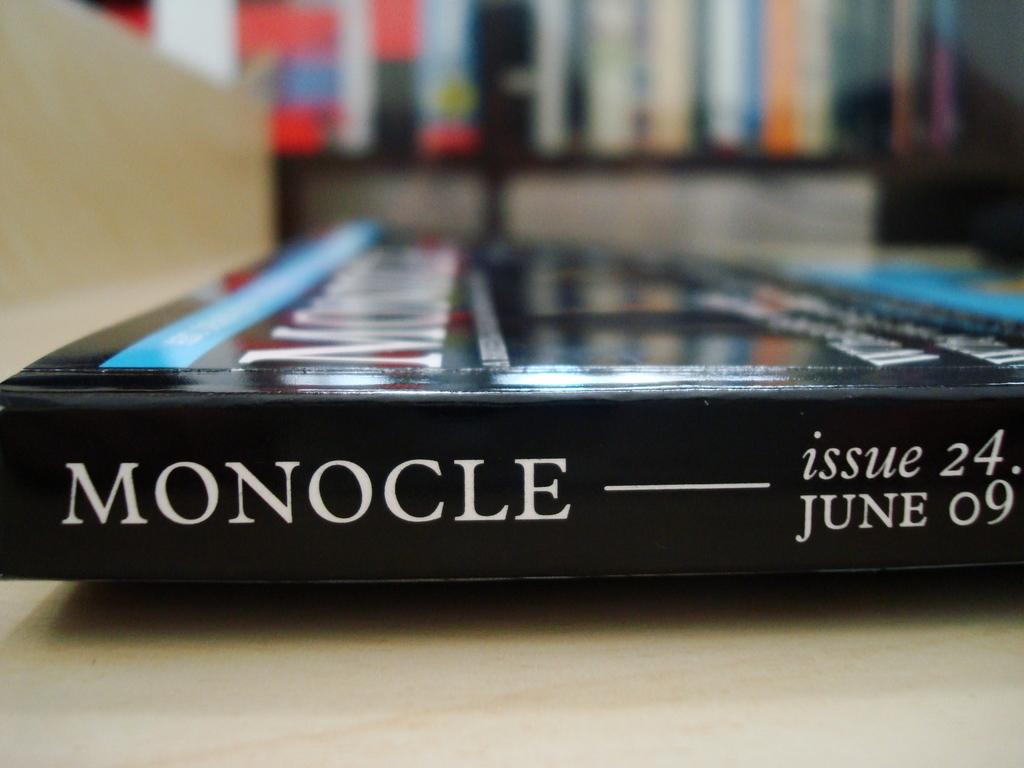<image>
Render a clear and concise summary of the photo. A book called Monocle was issue 24 and released on June 9 